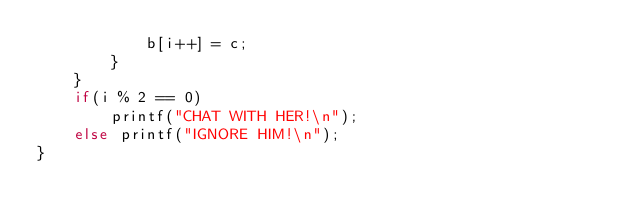Convert code to text. <code><loc_0><loc_0><loc_500><loc_500><_C_>            b[i++] = c;
        }
    }
    if(i % 2 == 0)
        printf("CHAT WITH HER!\n");
    else printf("IGNORE HIM!\n");
}</code> 